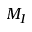<formula> <loc_0><loc_0><loc_500><loc_500>M _ { I }</formula> 